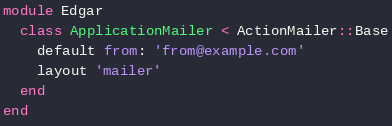Convert code to text. <code><loc_0><loc_0><loc_500><loc_500><_Ruby_>module Edgar
  class ApplicationMailer < ActionMailer::Base
    default from: 'from@example.com'
    layout 'mailer'
  end
end
</code> 